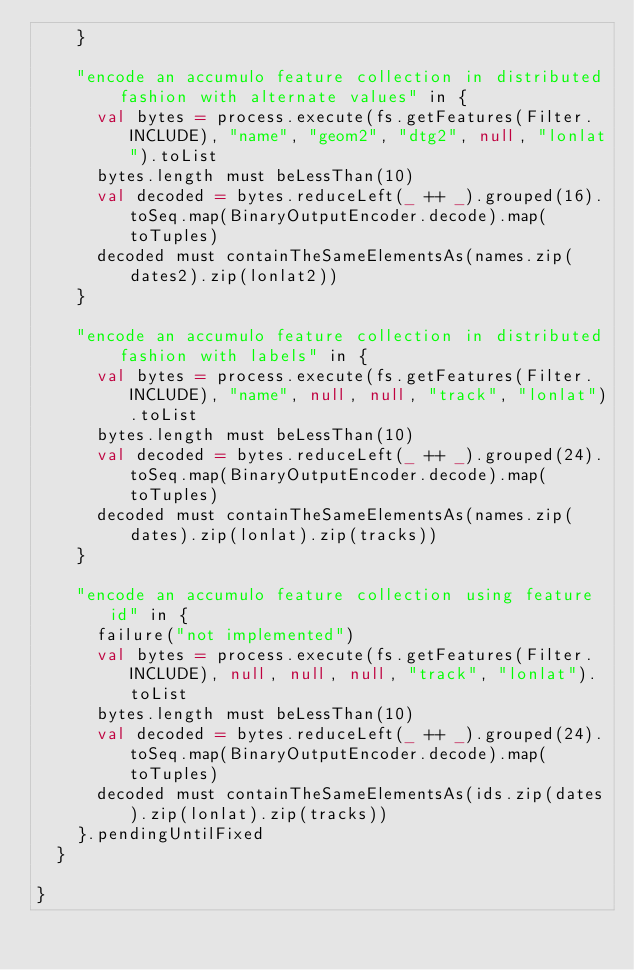<code> <loc_0><loc_0><loc_500><loc_500><_Scala_>    }

    "encode an accumulo feature collection in distributed fashion with alternate values" in {
      val bytes = process.execute(fs.getFeatures(Filter.INCLUDE), "name", "geom2", "dtg2", null, "lonlat").toList
      bytes.length must beLessThan(10)
      val decoded = bytes.reduceLeft(_ ++ _).grouped(16).toSeq.map(BinaryOutputEncoder.decode).map(toTuples)
      decoded must containTheSameElementsAs(names.zip(dates2).zip(lonlat2))
    }

    "encode an accumulo feature collection in distributed fashion with labels" in {
      val bytes = process.execute(fs.getFeatures(Filter.INCLUDE), "name", null, null, "track", "lonlat").toList
      bytes.length must beLessThan(10)
      val decoded = bytes.reduceLeft(_ ++ _).grouped(24).toSeq.map(BinaryOutputEncoder.decode).map(toTuples)
      decoded must containTheSameElementsAs(names.zip(dates).zip(lonlat).zip(tracks))
    }

    "encode an accumulo feature collection using feature id" in {
      failure("not implemented")
      val bytes = process.execute(fs.getFeatures(Filter.INCLUDE), null, null, null, "track", "lonlat").toList
      bytes.length must beLessThan(10)
      val decoded = bytes.reduceLeft(_ ++ _).grouped(24).toSeq.map(BinaryOutputEncoder.decode).map(toTuples)
      decoded must containTheSameElementsAs(ids.zip(dates).zip(lonlat).zip(tracks))
    }.pendingUntilFixed
  }

}
</code> 